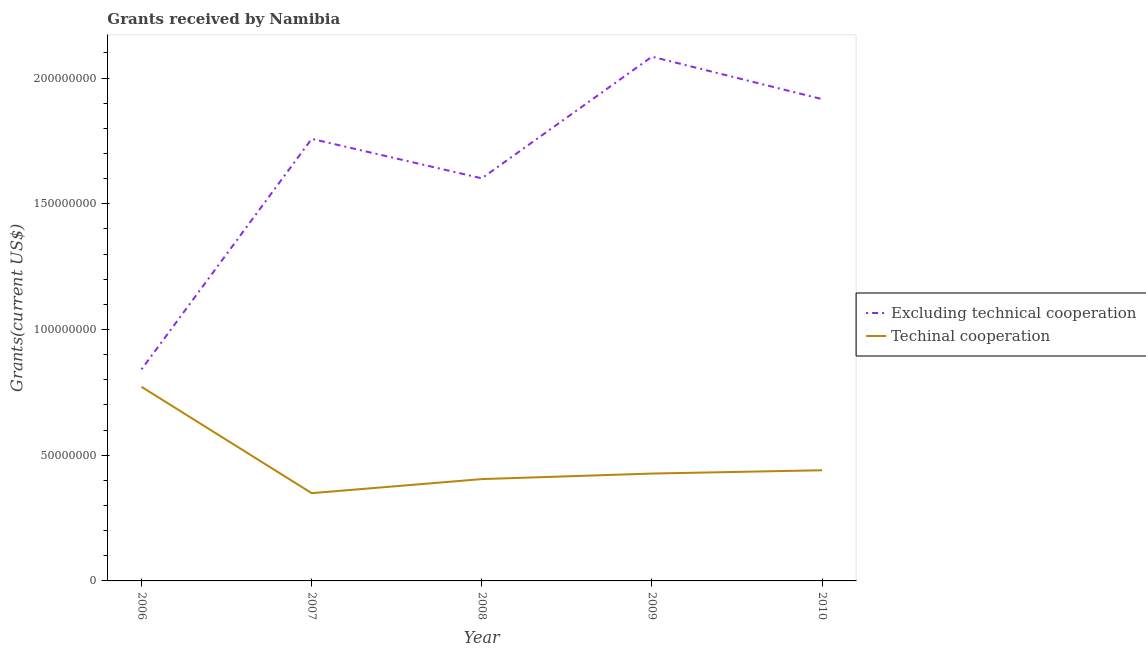Does the line corresponding to amount of grants received(including technical cooperation) intersect with the line corresponding to amount of grants received(excluding technical cooperation)?
Give a very brief answer. No. What is the amount of grants received(excluding technical cooperation) in 2007?
Give a very brief answer. 1.76e+08. Across all years, what is the maximum amount of grants received(excluding technical cooperation)?
Give a very brief answer. 2.09e+08. Across all years, what is the minimum amount of grants received(excluding technical cooperation)?
Your response must be concise. 8.42e+07. In which year was the amount of grants received(excluding technical cooperation) maximum?
Offer a very short reply. 2009. What is the total amount of grants received(including technical cooperation) in the graph?
Keep it short and to the point. 2.39e+08. What is the difference between the amount of grants received(including technical cooperation) in 2007 and that in 2010?
Your response must be concise. -9.11e+06. What is the difference between the amount of grants received(excluding technical cooperation) in 2006 and the amount of grants received(including technical cooperation) in 2010?
Provide a succinct answer. 4.01e+07. What is the average amount of grants received(including technical cooperation) per year?
Give a very brief answer. 4.79e+07. In the year 2009, what is the difference between the amount of grants received(including technical cooperation) and amount of grants received(excluding technical cooperation)?
Your response must be concise. -1.66e+08. In how many years, is the amount of grants received(excluding technical cooperation) greater than 20000000 US$?
Provide a succinct answer. 5. What is the ratio of the amount of grants received(including technical cooperation) in 2006 to that in 2007?
Your response must be concise. 2.21. Is the difference between the amount of grants received(excluding technical cooperation) in 2006 and 2009 greater than the difference between the amount of grants received(including technical cooperation) in 2006 and 2009?
Your response must be concise. No. What is the difference between the highest and the second highest amount of grants received(excluding technical cooperation)?
Your answer should be very brief. 1.69e+07. What is the difference between the highest and the lowest amount of grants received(including technical cooperation)?
Give a very brief answer. 4.23e+07. In how many years, is the amount of grants received(including technical cooperation) greater than the average amount of grants received(including technical cooperation) taken over all years?
Offer a terse response. 1. Is the sum of the amount of grants received(including technical cooperation) in 2009 and 2010 greater than the maximum amount of grants received(excluding technical cooperation) across all years?
Keep it short and to the point. No. Does the amount of grants received(excluding technical cooperation) monotonically increase over the years?
Offer a very short reply. No. Is the amount of grants received(including technical cooperation) strictly greater than the amount of grants received(excluding technical cooperation) over the years?
Your answer should be compact. No. How many lines are there?
Provide a succinct answer. 2. Are the values on the major ticks of Y-axis written in scientific E-notation?
Your answer should be compact. No. How many legend labels are there?
Make the answer very short. 2. How are the legend labels stacked?
Ensure brevity in your answer.  Vertical. What is the title of the graph?
Make the answer very short. Grants received by Namibia. What is the label or title of the X-axis?
Make the answer very short. Year. What is the label or title of the Y-axis?
Ensure brevity in your answer.  Grants(current US$). What is the Grants(current US$) in Excluding technical cooperation in 2006?
Offer a terse response. 8.42e+07. What is the Grants(current US$) of Techinal cooperation in 2006?
Provide a short and direct response. 7.72e+07. What is the Grants(current US$) in Excluding technical cooperation in 2007?
Your response must be concise. 1.76e+08. What is the Grants(current US$) of Techinal cooperation in 2007?
Offer a terse response. 3.49e+07. What is the Grants(current US$) of Excluding technical cooperation in 2008?
Your answer should be very brief. 1.60e+08. What is the Grants(current US$) of Techinal cooperation in 2008?
Provide a short and direct response. 4.05e+07. What is the Grants(current US$) of Excluding technical cooperation in 2009?
Provide a short and direct response. 2.09e+08. What is the Grants(current US$) in Techinal cooperation in 2009?
Provide a short and direct response. 4.27e+07. What is the Grants(current US$) in Excluding technical cooperation in 2010?
Your answer should be compact. 1.92e+08. What is the Grants(current US$) of Techinal cooperation in 2010?
Your response must be concise. 4.40e+07. Across all years, what is the maximum Grants(current US$) of Excluding technical cooperation?
Provide a succinct answer. 2.09e+08. Across all years, what is the maximum Grants(current US$) of Techinal cooperation?
Your response must be concise. 7.72e+07. Across all years, what is the minimum Grants(current US$) in Excluding technical cooperation?
Make the answer very short. 8.42e+07. Across all years, what is the minimum Grants(current US$) of Techinal cooperation?
Your answer should be compact. 3.49e+07. What is the total Grants(current US$) of Excluding technical cooperation in the graph?
Your answer should be very brief. 8.20e+08. What is the total Grants(current US$) in Techinal cooperation in the graph?
Provide a succinct answer. 2.39e+08. What is the difference between the Grants(current US$) in Excluding technical cooperation in 2006 and that in 2007?
Make the answer very short. -9.17e+07. What is the difference between the Grants(current US$) of Techinal cooperation in 2006 and that in 2007?
Make the answer very short. 4.23e+07. What is the difference between the Grants(current US$) of Excluding technical cooperation in 2006 and that in 2008?
Make the answer very short. -7.60e+07. What is the difference between the Grants(current US$) of Techinal cooperation in 2006 and that in 2008?
Provide a succinct answer. 3.67e+07. What is the difference between the Grants(current US$) in Excluding technical cooperation in 2006 and that in 2009?
Provide a short and direct response. -1.24e+08. What is the difference between the Grants(current US$) in Techinal cooperation in 2006 and that in 2009?
Ensure brevity in your answer.  3.45e+07. What is the difference between the Grants(current US$) in Excluding technical cooperation in 2006 and that in 2010?
Provide a succinct answer. -1.07e+08. What is the difference between the Grants(current US$) of Techinal cooperation in 2006 and that in 2010?
Your answer should be compact. 3.32e+07. What is the difference between the Grants(current US$) of Excluding technical cooperation in 2007 and that in 2008?
Keep it short and to the point. 1.57e+07. What is the difference between the Grants(current US$) of Techinal cooperation in 2007 and that in 2008?
Keep it short and to the point. -5.59e+06. What is the difference between the Grants(current US$) of Excluding technical cooperation in 2007 and that in 2009?
Give a very brief answer. -3.27e+07. What is the difference between the Grants(current US$) of Techinal cooperation in 2007 and that in 2009?
Offer a very short reply. -7.79e+06. What is the difference between the Grants(current US$) of Excluding technical cooperation in 2007 and that in 2010?
Give a very brief answer. -1.58e+07. What is the difference between the Grants(current US$) in Techinal cooperation in 2007 and that in 2010?
Your response must be concise. -9.11e+06. What is the difference between the Grants(current US$) in Excluding technical cooperation in 2008 and that in 2009?
Offer a terse response. -4.84e+07. What is the difference between the Grants(current US$) of Techinal cooperation in 2008 and that in 2009?
Your answer should be compact. -2.20e+06. What is the difference between the Grants(current US$) of Excluding technical cooperation in 2008 and that in 2010?
Your response must be concise. -3.15e+07. What is the difference between the Grants(current US$) of Techinal cooperation in 2008 and that in 2010?
Offer a terse response. -3.52e+06. What is the difference between the Grants(current US$) of Excluding technical cooperation in 2009 and that in 2010?
Provide a succinct answer. 1.69e+07. What is the difference between the Grants(current US$) of Techinal cooperation in 2009 and that in 2010?
Offer a very short reply. -1.32e+06. What is the difference between the Grants(current US$) of Excluding technical cooperation in 2006 and the Grants(current US$) of Techinal cooperation in 2007?
Offer a very short reply. 4.92e+07. What is the difference between the Grants(current US$) of Excluding technical cooperation in 2006 and the Grants(current US$) of Techinal cooperation in 2008?
Give a very brief answer. 4.36e+07. What is the difference between the Grants(current US$) of Excluding technical cooperation in 2006 and the Grants(current US$) of Techinal cooperation in 2009?
Offer a terse response. 4.14e+07. What is the difference between the Grants(current US$) of Excluding technical cooperation in 2006 and the Grants(current US$) of Techinal cooperation in 2010?
Your response must be concise. 4.01e+07. What is the difference between the Grants(current US$) in Excluding technical cooperation in 2007 and the Grants(current US$) in Techinal cooperation in 2008?
Offer a terse response. 1.35e+08. What is the difference between the Grants(current US$) of Excluding technical cooperation in 2007 and the Grants(current US$) of Techinal cooperation in 2009?
Offer a very short reply. 1.33e+08. What is the difference between the Grants(current US$) in Excluding technical cooperation in 2007 and the Grants(current US$) in Techinal cooperation in 2010?
Provide a succinct answer. 1.32e+08. What is the difference between the Grants(current US$) of Excluding technical cooperation in 2008 and the Grants(current US$) of Techinal cooperation in 2009?
Your response must be concise. 1.17e+08. What is the difference between the Grants(current US$) of Excluding technical cooperation in 2008 and the Grants(current US$) of Techinal cooperation in 2010?
Your answer should be very brief. 1.16e+08. What is the difference between the Grants(current US$) of Excluding technical cooperation in 2009 and the Grants(current US$) of Techinal cooperation in 2010?
Give a very brief answer. 1.64e+08. What is the average Grants(current US$) of Excluding technical cooperation per year?
Keep it short and to the point. 1.64e+08. What is the average Grants(current US$) of Techinal cooperation per year?
Your answer should be compact. 4.79e+07. In the year 2006, what is the difference between the Grants(current US$) in Excluding technical cooperation and Grants(current US$) in Techinal cooperation?
Give a very brief answer. 6.95e+06. In the year 2007, what is the difference between the Grants(current US$) in Excluding technical cooperation and Grants(current US$) in Techinal cooperation?
Give a very brief answer. 1.41e+08. In the year 2008, what is the difference between the Grants(current US$) in Excluding technical cooperation and Grants(current US$) in Techinal cooperation?
Give a very brief answer. 1.20e+08. In the year 2009, what is the difference between the Grants(current US$) in Excluding technical cooperation and Grants(current US$) in Techinal cooperation?
Offer a terse response. 1.66e+08. In the year 2010, what is the difference between the Grants(current US$) of Excluding technical cooperation and Grants(current US$) of Techinal cooperation?
Your answer should be compact. 1.48e+08. What is the ratio of the Grants(current US$) in Excluding technical cooperation in 2006 to that in 2007?
Give a very brief answer. 0.48. What is the ratio of the Grants(current US$) of Techinal cooperation in 2006 to that in 2007?
Offer a terse response. 2.21. What is the ratio of the Grants(current US$) in Excluding technical cooperation in 2006 to that in 2008?
Make the answer very short. 0.53. What is the ratio of the Grants(current US$) in Techinal cooperation in 2006 to that in 2008?
Your response must be concise. 1.91. What is the ratio of the Grants(current US$) in Excluding technical cooperation in 2006 to that in 2009?
Give a very brief answer. 0.4. What is the ratio of the Grants(current US$) in Techinal cooperation in 2006 to that in 2009?
Offer a terse response. 1.81. What is the ratio of the Grants(current US$) in Excluding technical cooperation in 2006 to that in 2010?
Provide a succinct answer. 0.44. What is the ratio of the Grants(current US$) in Techinal cooperation in 2006 to that in 2010?
Offer a very short reply. 1.75. What is the ratio of the Grants(current US$) in Excluding technical cooperation in 2007 to that in 2008?
Provide a succinct answer. 1.1. What is the ratio of the Grants(current US$) of Techinal cooperation in 2007 to that in 2008?
Your answer should be very brief. 0.86. What is the ratio of the Grants(current US$) of Excluding technical cooperation in 2007 to that in 2009?
Offer a very short reply. 0.84. What is the ratio of the Grants(current US$) of Techinal cooperation in 2007 to that in 2009?
Provide a succinct answer. 0.82. What is the ratio of the Grants(current US$) in Excluding technical cooperation in 2007 to that in 2010?
Give a very brief answer. 0.92. What is the ratio of the Grants(current US$) of Techinal cooperation in 2007 to that in 2010?
Your answer should be very brief. 0.79. What is the ratio of the Grants(current US$) of Excluding technical cooperation in 2008 to that in 2009?
Offer a very short reply. 0.77. What is the ratio of the Grants(current US$) of Techinal cooperation in 2008 to that in 2009?
Provide a succinct answer. 0.95. What is the ratio of the Grants(current US$) in Excluding technical cooperation in 2008 to that in 2010?
Provide a succinct answer. 0.84. What is the ratio of the Grants(current US$) of Techinal cooperation in 2008 to that in 2010?
Your response must be concise. 0.92. What is the ratio of the Grants(current US$) in Excluding technical cooperation in 2009 to that in 2010?
Give a very brief answer. 1.09. What is the ratio of the Grants(current US$) of Techinal cooperation in 2009 to that in 2010?
Make the answer very short. 0.97. What is the difference between the highest and the second highest Grants(current US$) in Excluding technical cooperation?
Keep it short and to the point. 1.69e+07. What is the difference between the highest and the second highest Grants(current US$) of Techinal cooperation?
Ensure brevity in your answer.  3.32e+07. What is the difference between the highest and the lowest Grants(current US$) in Excluding technical cooperation?
Your answer should be compact. 1.24e+08. What is the difference between the highest and the lowest Grants(current US$) in Techinal cooperation?
Make the answer very short. 4.23e+07. 